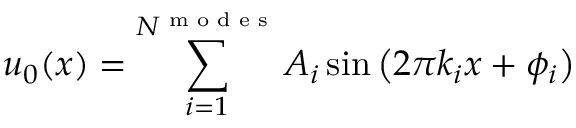<formula> <loc_0><loc_0><loc_500><loc_500>u _ { 0 } ( x ) = \sum _ { i = 1 } ^ { N ^ { m o d e s } } A _ { i } \sin { \left ( 2 \pi k _ { i } x + \phi _ { i } \right ) }</formula> 